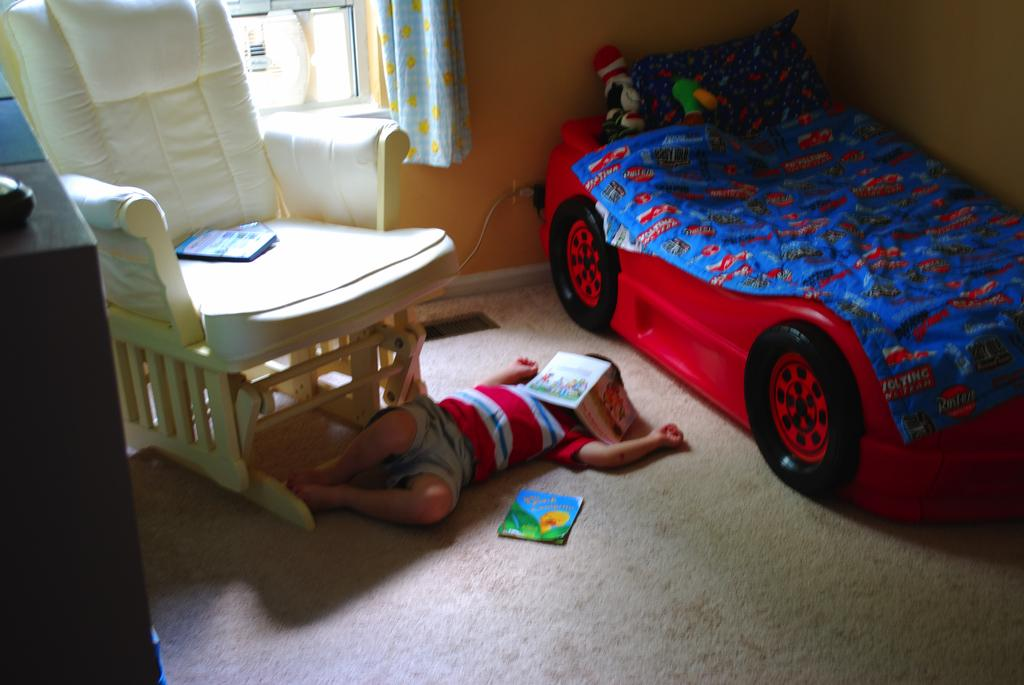What is the boy doing in the image? The boy is laying on the floor in the image. What piece of furniture is present in the image besides the floor? There is a bed and a chair in the image. What is on the chair in the image? There are books on the chair in the image. What is visible on the wall in the image? There is a wall in the image. What type of advertisement can be seen on the boy's hair in the image? There is no advertisement on the boy's hair in the image, as there is no mention of hair or any advertisement in the provided facts. 